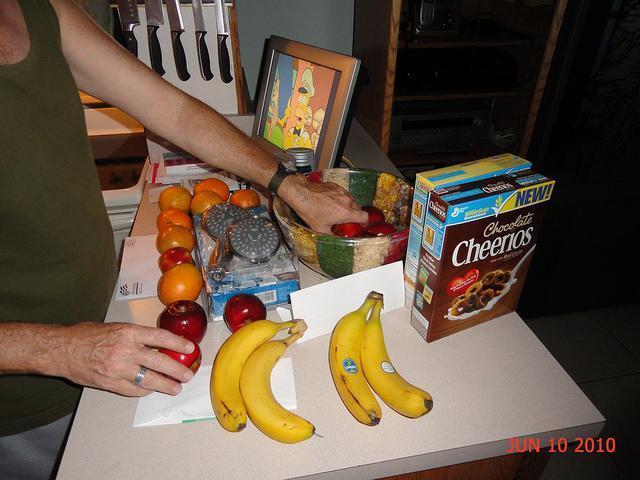How many bananas are there?
Give a very brief answer. 4. How many bananas are visible?
Give a very brief answer. 4. How many bananas are depicted?
Give a very brief answer. 4. How many bananas is the person holding?
Give a very brief answer. 0. How many boxes are there?
Give a very brief answer. 2. How many bananas can be seen?
Give a very brief answer. 4. How many dining tables can you see?
Give a very brief answer. 2. 